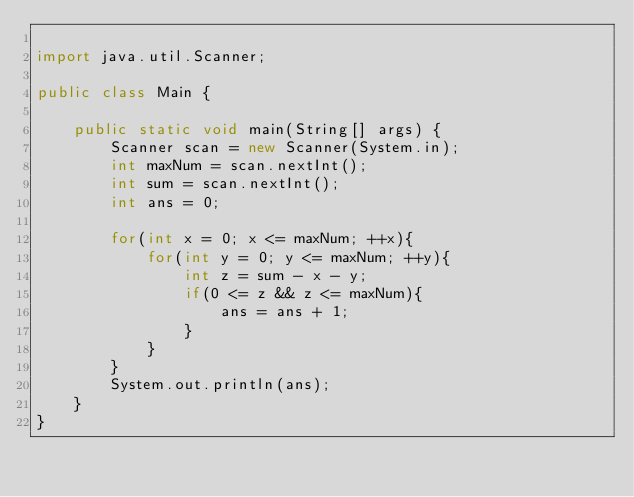Convert code to text. <code><loc_0><loc_0><loc_500><loc_500><_Java_>
import java.util.Scanner;

public class Main {

	public static void main(String[] args) {
		Scanner scan = new Scanner(System.in);
		int maxNum = scan.nextInt();
		int sum = scan.nextInt();
		int ans = 0;
		
		for(int x = 0; x <= maxNum; ++x){
			for(int y = 0; y <= maxNum; ++y){
				int z = sum - x - y;
				if(0 <= z && z <= maxNum){
					ans = ans + 1;
				}
			}
		}
		System.out.println(ans);
	}
}
</code> 